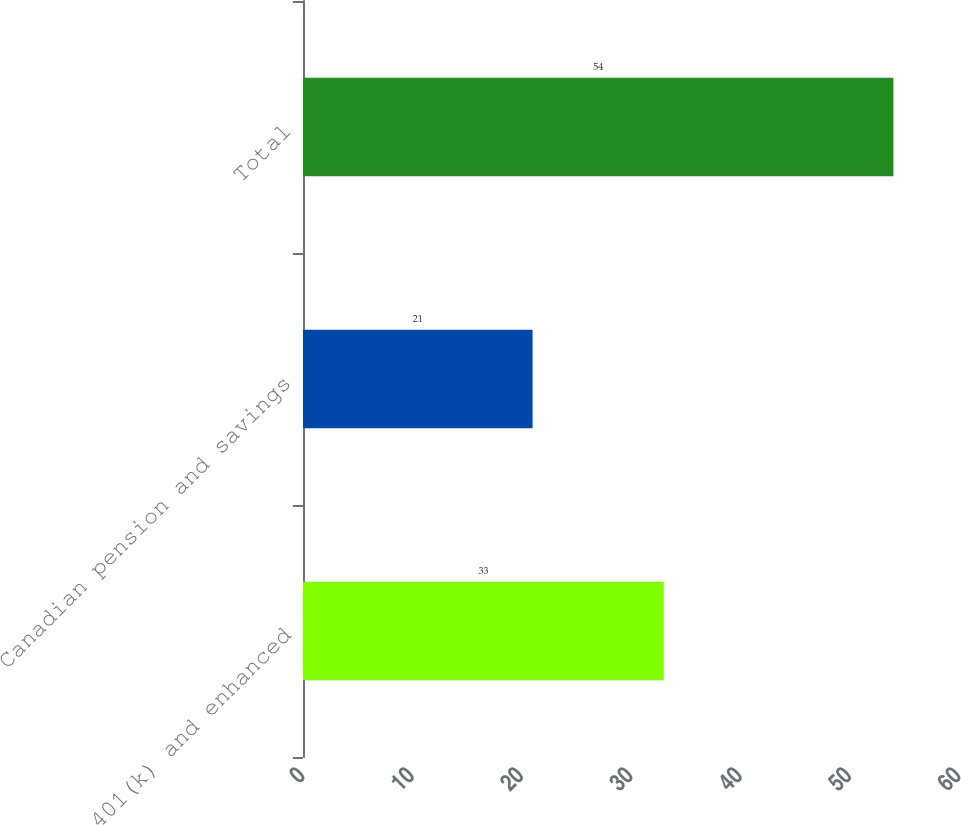Convert chart to OTSL. <chart><loc_0><loc_0><loc_500><loc_500><bar_chart><fcel>401(k) and enhanced<fcel>Canadian pension and savings<fcel>Total<nl><fcel>33<fcel>21<fcel>54<nl></chart> 